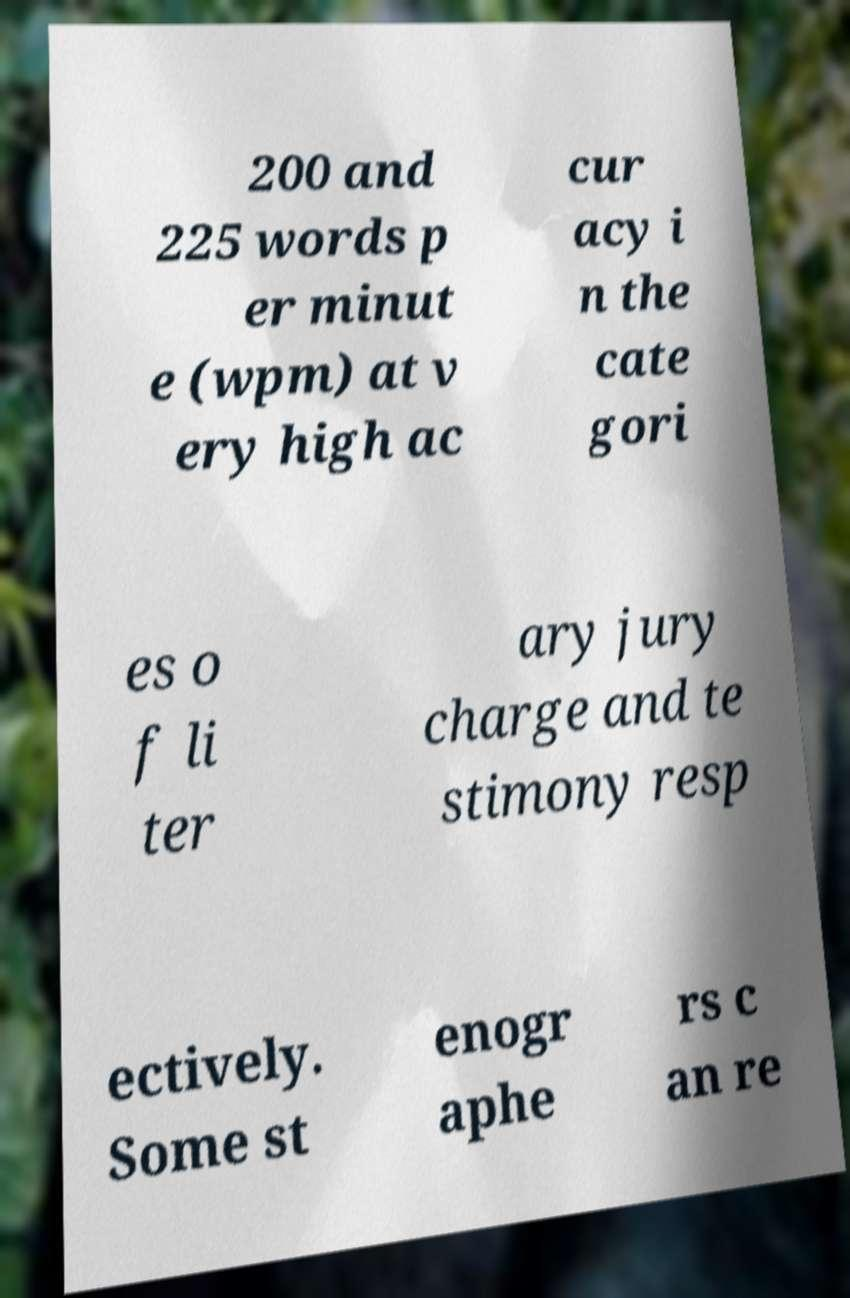Could you extract and type out the text from this image? 200 and 225 words p er minut e (wpm) at v ery high ac cur acy i n the cate gori es o f li ter ary jury charge and te stimony resp ectively. Some st enogr aphe rs c an re 